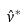<formula> <loc_0><loc_0><loc_500><loc_500>\hat { v } ^ { * }</formula> 